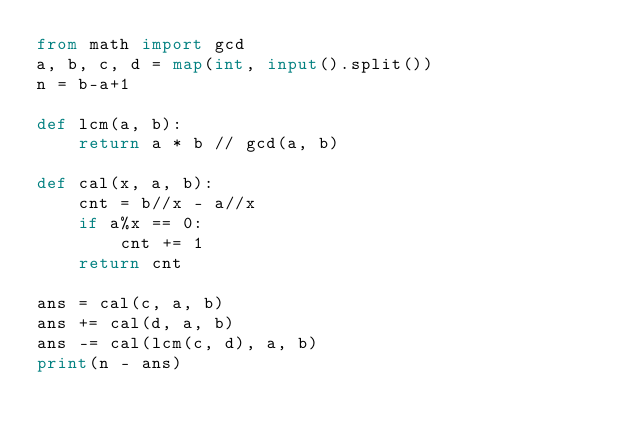Convert code to text. <code><loc_0><loc_0><loc_500><loc_500><_Python_>from math import gcd 
a, b, c, d = map(int, input().split())
n = b-a+1

def lcm(a, b):
    return a * b // gcd(a, b)

def cal(x, a, b):
    cnt = b//x - a//x
    if a%x == 0:
        cnt += 1
    return cnt

ans = cal(c, a, b)
ans += cal(d, a, b)
ans -= cal(lcm(c, d), a, b)
print(n - ans)
</code> 